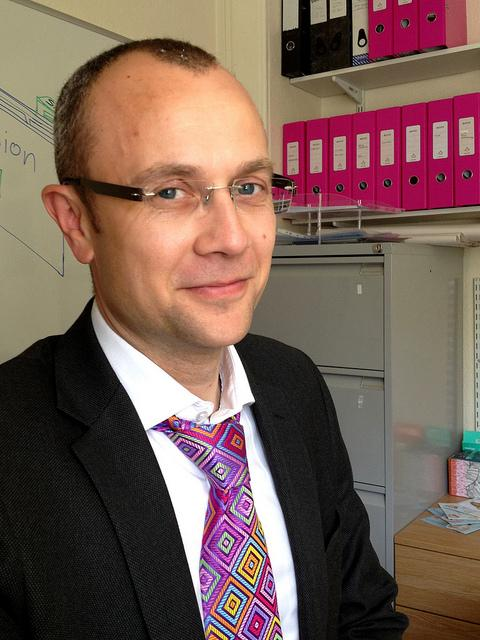What are the pink objects on the shelf? Please explain your reasoning. binders. He has binders. 